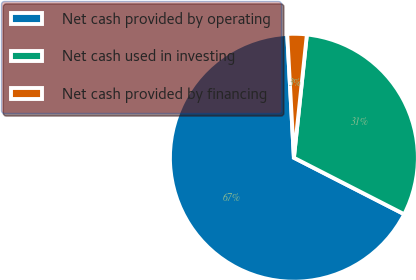Convert chart to OTSL. <chart><loc_0><loc_0><loc_500><loc_500><pie_chart><fcel>Net cash provided by operating<fcel>Net cash used in investing<fcel>Net cash provided by financing<nl><fcel>66.61%<fcel>30.86%<fcel>2.53%<nl></chart> 